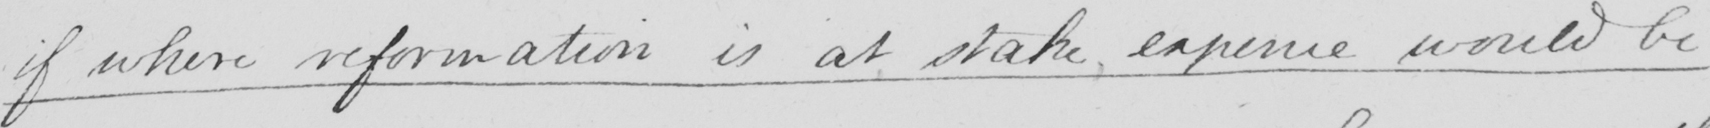Please provide the text content of this handwritten line. if where reformation is at stake expence would be 